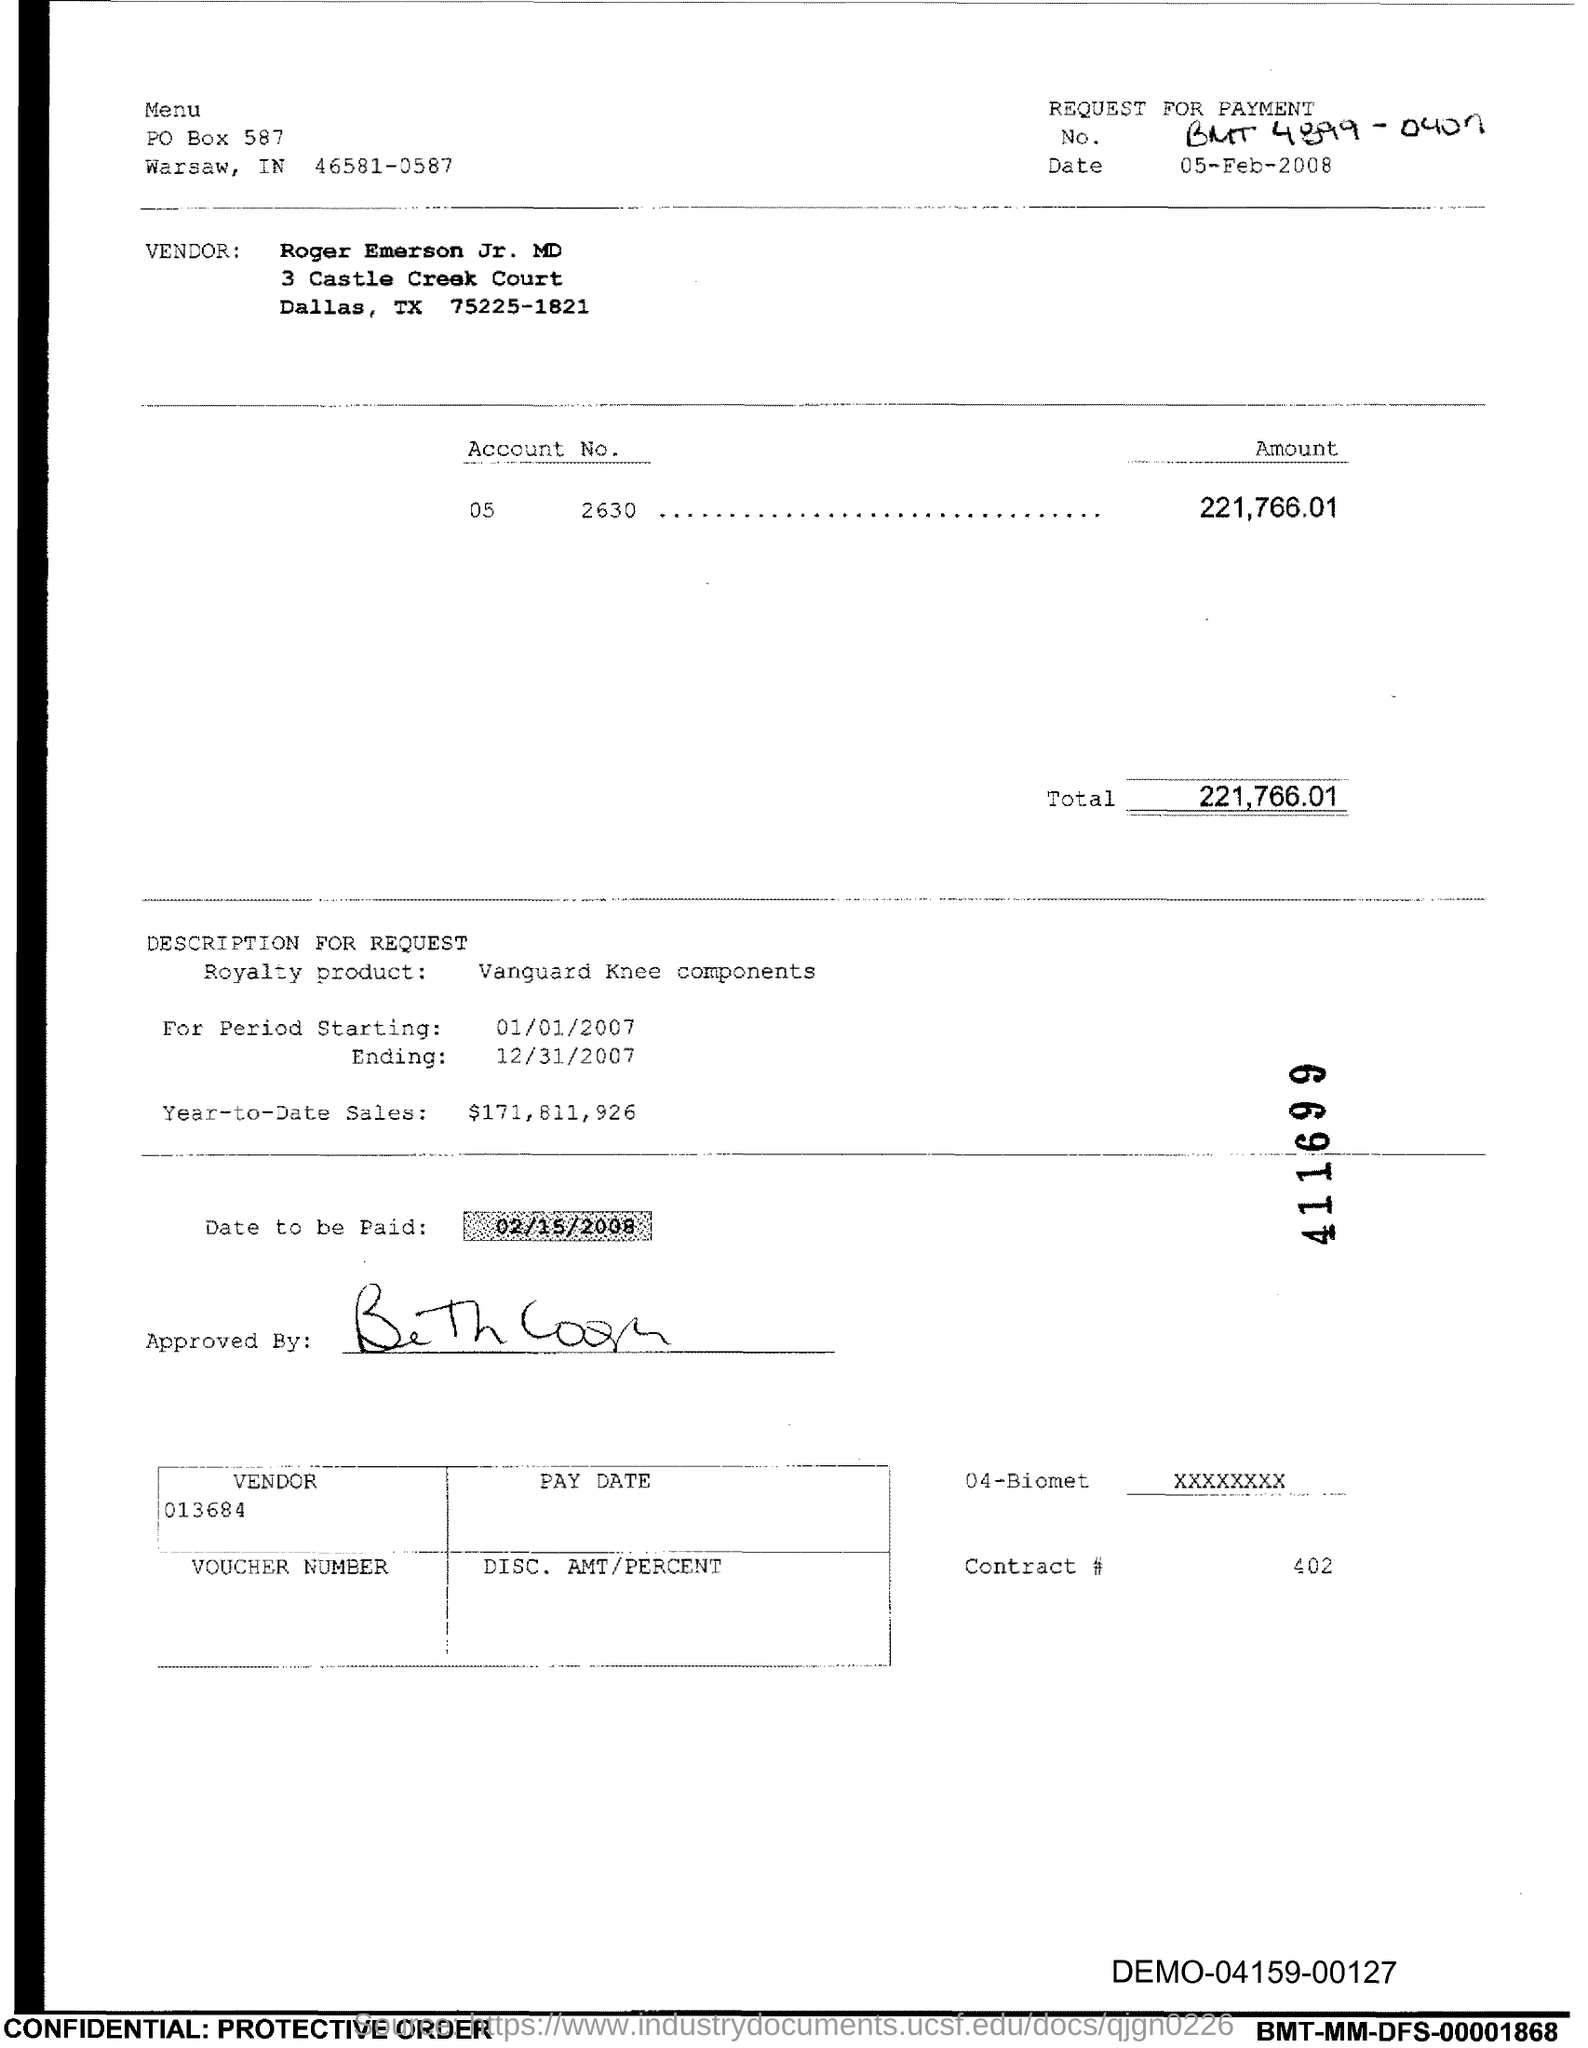Outline some significant characteristics in this image. The total is 221,766.01. The Contract Number is 402, as declared. 